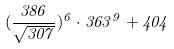<formula> <loc_0><loc_0><loc_500><loc_500>( \frac { 3 8 6 } { \sqrt { 3 0 7 } } ) ^ { 6 } \cdot 3 6 3 ^ { 9 } + 4 0 4</formula> 